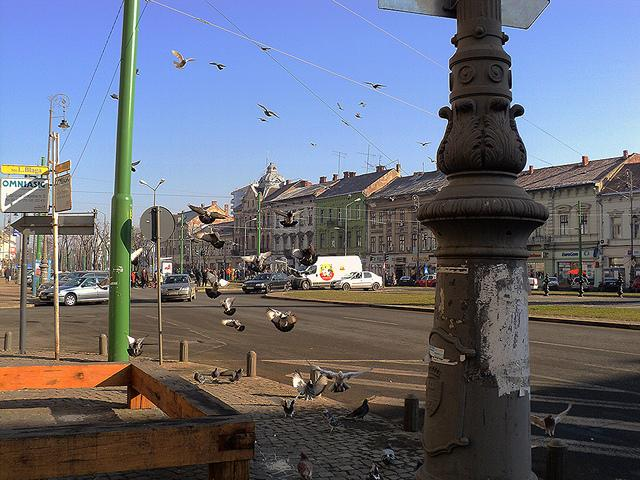Those birds are related to what other type of bird?

Choices:
A) raven
B) robin
C) peacock
D) dove dove 